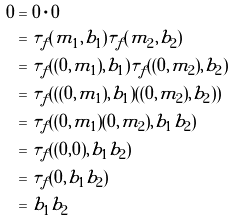Convert formula to latex. <formula><loc_0><loc_0><loc_500><loc_500>0 & = 0 \cdot 0 \\ & = \tau _ { f } ( m _ { 1 } , b _ { 1 } ) \tau _ { f } ( m _ { 2 } , b _ { 2 } ) \\ & = \tau _ { f } ( ( 0 , m _ { 1 } ) , b _ { 1 } ) \tau _ { f } ( ( 0 , m _ { 2 } ) , b _ { 2 } ) \\ & = \tau _ { f } ( ( ( 0 , m _ { 1 } ) , b _ { 1 } ) ( ( 0 , m _ { 2 } ) , b _ { 2 } ) ) \\ & = \tau _ { f } ( ( 0 , m _ { 1 } ) ( 0 , m _ { 2 } ) , b _ { 1 } b _ { 2 } ) \\ & = \tau _ { f } ( ( 0 , 0 ) , b _ { 1 } b _ { 2 } ) \\ & = \tau _ { f } ( 0 , b _ { 1 } b _ { 2 } ) \\ & = b _ { 1 } b _ { 2 }</formula> 